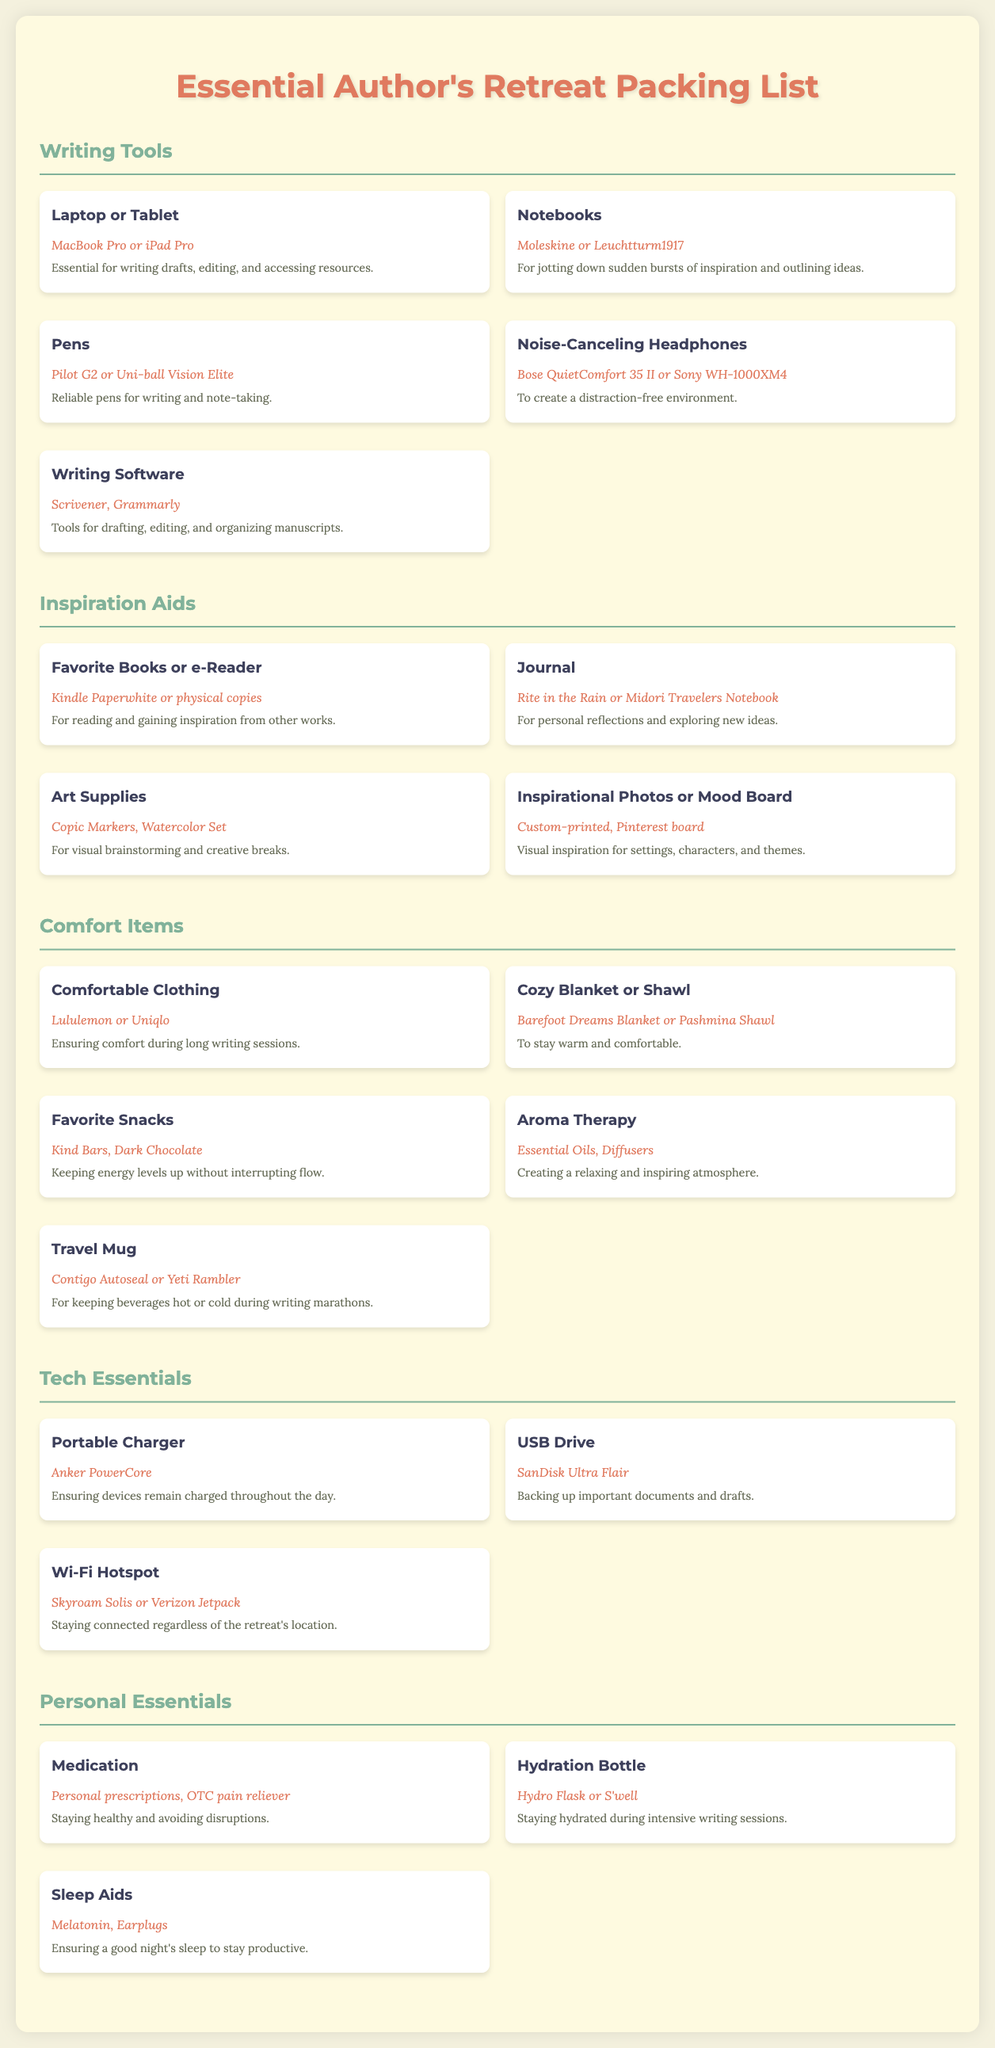What is the title of the document? The title is prominently displayed at the top of the document, serving as the main headline.
Answer: Essential Author's Retreat Packing List How many categories are listed in the document? The document contains several sections categorized for different items, which can be counted.
Answer: 5 What brand is recommended for Comfortable Clothing? The brand name is mentioned under the "Comfort Items" category for clothing, indicating a specific option.
Answer: Lululemon or Uniqlo What type of writing software is listed? The document specifies certain software tools designed for authors to aid in their writing process.
Answer: Scrivener, Grammarly Which item is suggested for a distraction-free environment? The document identifies a specific item that helps minimize distractions while writing.
Answer: Noise-Canceling Headphones What is included in the Personal Essentials category for staying hydrated? The essential item for hydration is mentioned under the specific category for personal needs.
Answer: Hydration Bottle What appliance helps keep beverages hot or cold during writing marathons? The document specifies a product designed for maintaining the temperature of drinks while working.
Answer: Travel Mug Name one item recommended for visual brainstorming. An item for visual creativity and brainstorming is noted for its purpose in the category dedicated to inspiration.
Answer: Art Supplies 